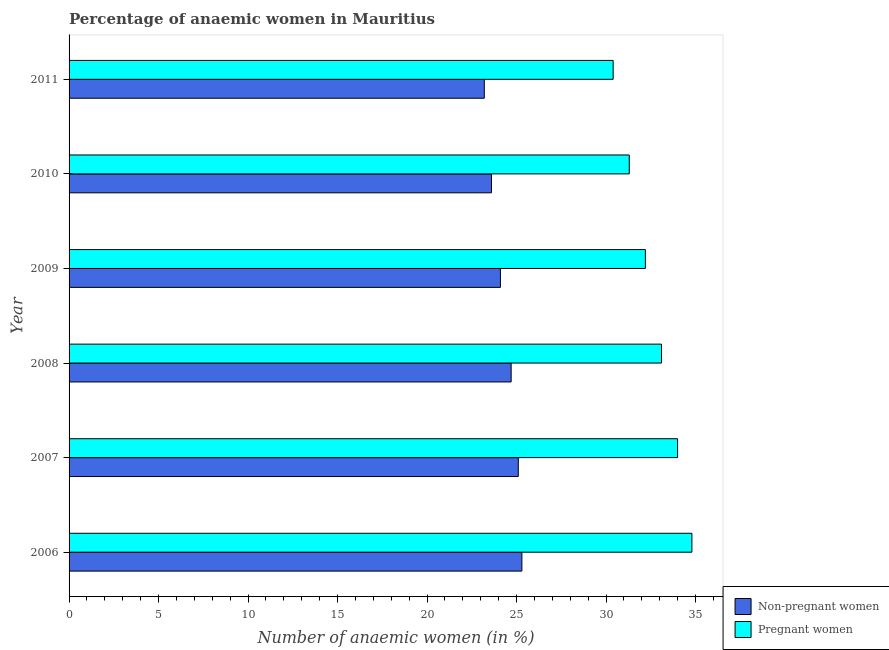How many different coloured bars are there?
Make the answer very short. 2. How many groups of bars are there?
Give a very brief answer. 6. Are the number of bars per tick equal to the number of legend labels?
Your answer should be very brief. Yes. How many bars are there on the 4th tick from the top?
Offer a terse response. 2. How many bars are there on the 6th tick from the bottom?
Provide a short and direct response. 2. What is the percentage of pregnant anaemic women in 2006?
Your answer should be very brief. 34.8. Across all years, what is the maximum percentage of pregnant anaemic women?
Provide a short and direct response. 34.8. Across all years, what is the minimum percentage of non-pregnant anaemic women?
Provide a short and direct response. 23.2. In which year was the percentage of pregnant anaemic women minimum?
Offer a terse response. 2011. What is the total percentage of pregnant anaemic women in the graph?
Offer a very short reply. 195.8. What is the difference between the percentage of pregnant anaemic women in 2009 and that in 2010?
Provide a succinct answer. 0.9. What is the difference between the percentage of non-pregnant anaemic women in 2011 and the percentage of pregnant anaemic women in 2008?
Provide a succinct answer. -9.9. What is the average percentage of pregnant anaemic women per year?
Offer a very short reply. 32.63. In how many years, is the percentage of pregnant anaemic women greater than 12 %?
Offer a terse response. 6. What is the ratio of the percentage of non-pregnant anaemic women in 2009 to that in 2011?
Provide a succinct answer. 1.04. Is the percentage of non-pregnant anaemic women in 2007 less than that in 2011?
Offer a very short reply. No. In how many years, is the percentage of non-pregnant anaemic women greater than the average percentage of non-pregnant anaemic women taken over all years?
Provide a short and direct response. 3. What does the 1st bar from the top in 2006 represents?
Your answer should be compact. Pregnant women. What does the 2nd bar from the bottom in 2009 represents?
Ensure brevity in your answer.  Pregnant women. How many years are there in the graph?
Keep it short and to the point. 6. What is the difference between two consecutive major ticks on the X-axis?
Ensure brevity in your answer.  5. Are the values on the major ticks of X-axis written in scientific E-notation?
Give a very brief answer. No. How many legend labels are there?
Ensure brevity in your answer.  2. How are the legend labels stacked?
Provide a succinct answer. Vertical. What is the title of the graph?
Offer a terse response. Percentage of anaemic women in Mauritius. Does "Study and work" appear as one of the legend labels in the graph?
Provide a short and direct response. No. What is the label or title of the X-axis?
Your answer should be compact. Number of anaemic women (in %). What is the label or title of the Y-axis?
Provide a succinct answer. Year. What is the Number of anaemic women (in %) of Non-pregnant women in 2006?
Your answer should be compact. 25.3. What is the Number of anaemic women (in %) of Pregnant women in 2006?
Your response must be concise. 34.8. What is the Number of anaemic women (in %) of Non-pregnant women in 2007?
Your answer should be very brief. 25.1. What is the Number of anaemic women (in %) in Non-pregnant women in 2008?
Keep it short and to the point. 24.7. What is the Number of anaemic women (in %) in Pregnant women in 2008?
Your answer should be very brief. 33.1. What is the Number of anaemic women (in %) of Non-pregnant women in 2009?
Offer a terse response. 24.1. What is the Number of anaemic women (in %) of Pregnant women in 2009?
Your answer should be very brief. 32.2. What is the Number of anaemic women (in %) in Non-pregnant women in 2010?
Ensure brevity in your answer.  23.6. What is the Number of anaemic women (in %) of Pregnant women in 2010?
Your response must be concise. 31.3. What is the Number of anaemic women (in %) of Non-pregnant women in 2011?
Keep it short and to the point. 23.2. What is the Number of anaemic women (in %) of Pregnant women in 2011?
Your answer should be compact. 30.4. Across all years, what is the maximum Number of anaemic women (in %) in Non-pregnant women?
Provide a short and direct response. 25.3. Across all years, what is the maximum Number of anaemic women (in %) in Pregnant women?
Give a very brief answer. 34.8. Across all years, what is the minimum Number of anaemic women (in %) in Non-pregnant women?
Provide a short and direct response. 23.2. Across all years, what is the minimum Number of anaemic women (in %) of Pregnant women?
Provide a short and direct response. 30.4. What is the total Number of anaemic women (in %) of Non-pregnant women in the graph?
Provide a succinct answer. 146. What is the total Number of anaemic women (in %) of Pregnant women in the graph?
Your response must be concise. 195.8. What is the difference between the Number of anaemic women (in %) of Pregnant women in 2006 and that in 2007?
Your response must be concise. 0.8. What is the difference between the Number of anaemic women (in %) of Non-pregnant women in 2006 and that in 2008?
Your response must be concise. 0.6. What is the difference between the Number of anaemic women (in %) in Non-pregnant women in 2006 and that in 2009?
Make the answer very short. 1.2. What is the difference between the Number of anaemic women (in %) in Non-pregnant women in 2006 and that in 2010?
Keep it short and to the point. 1.7. What is the difference between the Number of anaemic women (in %) of Non-pregnant women in 2007 and that in 2008?
Offer a terse response. 0.4. What is the difference between the Number of anaemic women (in %) of Pregnant women in 2007 and that in 2008?
Your response must be concise. 0.9. What is the difference between the Number of anaemic women (in %) of Non-pregnant women in 2007 and that in 2009?
Provide a short and direct response. 1. What is the difference between the Number of anaemic women (in %) of Non-pregnant women in 2007 and that in 2010?
Your response must be concise. 1.5. What is the difference between the Number of anaemic women (in %) in Pregnant women in 2007 and that in 2010?
Make the answer very short. 2.7. What is the difference between the Number of anaemic women (in %) in Non-pregnant women in 2007 and that in 2011?
Your response must be concise. 1.9. What is the difference between the Number of anaemic women (in %) of Non-pregnant women in 2008 and that in 2009?
Give a very brief answer. 0.6. What is the difference between the Number of anaemic women (in %) in Pregnant women in 2008 and that in 2009?
Your response must be concise. 0.9. What is the difference between the Number of anaemic women (in %) in Pregnant women in 2009 and that in 2010?
Offer a very short reply. 0.9. What is the difference between the Number of anaemic women (in %) of Non-pregnant women in 2009 and that in 2011?
Ensure brevity in your answer.  0.9. What is the difference between the Number of anaemic women (in %) of Pregnant women in 2009 and that in 2011?
Make the answer very short. 1.8. What is the difference between the Number of anaemic women (in %) in Pregnant women in 2010 and that in 2011?
Your answer should be compact. 0.9. What is the difference between the Number of anaemic women (in %) in Non-pregnant women in 2006 and the Number of anaemic women (in %) in Pregnant women in 2008?
Your answer should be very brief. -7.8. What is the difference between the Number of anaemic women (in %) in Non-pregnant women in 2006 and the Number of anaemic women (in %) in Pregnant women in 2009?
Keep it short and to the point. -6.9. What is the difference between the Number of anaemic women (in %) in Non-pregnant women in 2006 and the Number of anaemic women (in %) in Pregnant women in 2011?
Keep it short and to the point. -5.1. What is the difference between the Number of anaemic women (in %) in Non-pregnant women in 2007 and the Number of anaemic women (in %) in Pregnant women in 2010?
Provide a short and direct response. -6.2. What is the difference between the Number of anaemic women (in %) of Non-pregnant women in 2008 and the Number of anaemic women (in %) of Pregnant women in 2009?
Keep it short and to the point. -7.5. What is the difference between the Number of anaemic women (in %) in Non-pregnant women in 2008 and the Number of anaemic women (in %) in Pregnant women in 2010?
Your response must be concise. -6.6. What is the difference between the Number of anaemic women (in %) in Non-pregnant women in 2008 and the Number of anaemic women (in %) in Pregnant women in 2011?
Provide a short and direct response. -5.7. What is the difference between the Number of anaemic women (in %) in Non-pregnant women in 2009 and the Number of anaemic women (in %) in Pregnant women in 2010?
Keep it short and to the point. -7.2. What is the average Number of anaemic women (in %) in Non-pregnant women per year?
Ensure brevity in your answer.  24.33. What is the average Number of anaemic women (in %) of Pregnant women per year?
Your answer should be compact. 32.63. In the year 2008, what is the difference between the Number of anaemic women (in %) of Non-pregnant women and Number of anaemic women (in %) of Pregnant women?
Provide a succinct answer. -8.4. In the year 2009, what is the difference between the Number of anaemic women (in %) of Non-pregnant women and Number of anaemic women (in %) of Pregnant women?
Ensure brevity in your answer.  -8.1. What is the ratio of the Number of anaemic women (in %) of Non-pregnant women in 2006 to that in 2007?
Offer a terse response. 1.01. What is the ratio of the Number of anaemic women (in %) in Pregnant women in 2006 to that in 2007?
Give a very brief answer. 1.02. What is the ratio of the Number of anaemic women (in %) in Non-pregnant women in 2006 to that in 2008?
Your answer should be very brief. 1.02. What is the ratio of the Number of anaemic women (in %) of Pregnant women in 2006 to that in 2008?
Your response must be concise. 1.05. What is the ratio of the Number of anaemic women (in %) of Non-pregnant women in 2006 to that in 2009?
Give a very brief answer. 1.05. What is the ratio of the Number of anaemic women (in %) in Pregnant women in 2006 to that in 2009?
Offer a very short reply. 1.08. What is the ratio of the Number of anaemic women (in %) in Non-pregnant women in 2006 to that in 2010?
Ensure brevity in your answer.  1.07. What is the ratio of the Number of anaemic women (in %) in Pregnant women in 2006 to that in 2010?
Give a very brief answer. 1.11. What is the ratio of the Number of anaemic women (in %) of Non-pregnant women in 2006 to that in 2011?
Offer a terse response. 1.09. What is the ratio of the Number of anaemic women (in %) of Pregnant women in 2006 to that in 2011?
Your answer should be very brief. 1.14. What is the ratio of the Number of anaemic women (in %) in Non-pregnant women in 2007 to that in 2008?
Keep it short and to the point. 1.02. What is the ratio of the Number of anaemic women (in %) of Pregnant women in 2007 to that in 2008?
Make the answer very short. 1.03. What is the ratio of the Number of anaemic women (in %) of Non-pregnant women in 2007 to that in 2009?
Make the answer very short. 1.04. What is the ratio of the Number of anaemic women (in %) in Pregnant women in 2007 to that in 2009?
Your answer should be very brief. 1.06. What is the ratio of the Number of anaemic women (in %) in Non-pregnant women in 2007 to that in 2010?
Your response must be concise. 1.06. What is the ratio of the Number of anaemic women (in %) of Pregnant women in 2007 to that in 2010?
Give a very brief answer. 1.09. What is the ratio of the Number of anaemic women (in %) in Non-pregnant women in 2007 to that in 2011?
Your answer should be very brief. 1.08. What is the ratio of the Number of anaemic women (in %) of Pregnant women in 2007 to that in 2011?
Offer a very short reply. 1.12. What is the ratio of the Number of anaemic women (in %) in Non-pregnant women in 2008 to that in 2009?
Your answer should be very brief. 1.02. What is the ratio of the Number of anaemic women (in %) in Pregnant women in 2008 to that in 2009?
Your answer should be very brief. 1.03. What is the ratio of the Number of anaemic women (in %) in Non-pregnant women in 2008 to that in 2010?
Provide a short and direct response. 1.05. What is the ratio of the Number of anaemic women (in %) in Pregnant women in 2008 to that in 2010?
Offer a very short reply. 1.06. What is the ratio of the Number of anaemic women (in %) in Non-pregnant women in 2008 to that in 2011?
Offer a very short reply. 1.06. What is the ratio of the Number of anaemic women (in %) of Pregnant women in 2008 to that in 2011?
Your response must be concise. 1.09. What is the ratio of the Number of anaemic women (in %) in Non-pregnant women in 2009 to that in 2010?
Provide a short and direct response. 1.02. What is the ratio of the Number of anaemic women (in %) of Pregnant women in 2009 to that in 2010?
Offer a terse response. 1.03. What is the ratio of the Number of anaemic women (in %) in Non-pregnant women in 2009 to that in 2011?
Make the answer very short. 1.04. What is the ratio of the Number of anaemic women (in %) of Pregnant women in 2009 to that in 2011?
Your answer should be compact. 1.06. What is the ratio of the Number of anaemic women (in %) in Non-pregnant women in 2010 to that in 2011?
Provide a short and direct response. 1.02. What is the ratio of the Number of anaemic women (in %) in Pregnant women in 2010 to that in 2011?
Make the answer very short. 1.03. What is the difference between the highest and the second highest Number of anaemic women (in %) of Non-pregnant women?
Your answer should be very brief. 0.2. What is the difference between the highest and the lowest Number of anaemic women (in %) in Non-pregnant women?
Your answer should be compact. 2.1. What is the difference between the highest and the lowest Number of anaemic women (in %) in Pregnant women?
Offer a very short reply. 4.4. 